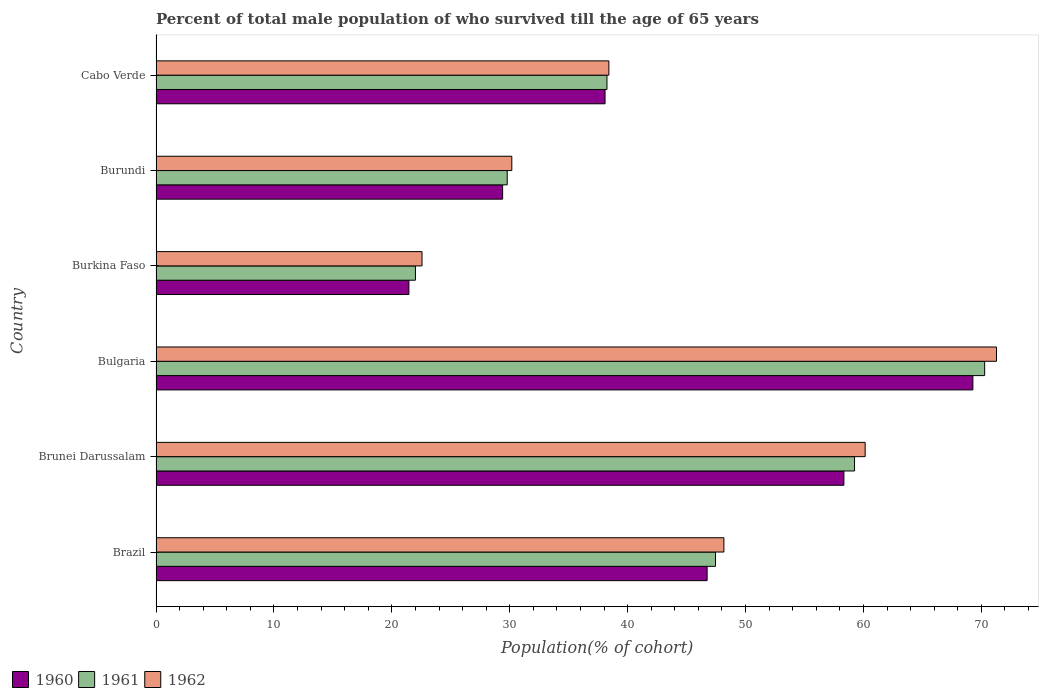How many different coloured bars are there?
Make the answer very short. 3. How many groups of bars are there?
Offer a terse response. 6. Are the number of bars on each tick of the Y-axis equal?
Keep it short and to the point. Yes. How many bars are there on the 2nd tick from the top?
Offer a terse response. 3. What is the label of the 4th group of bars from the top?
Ensure brevity in your answer.  Bulgaria. In how many cases, is the number of bars for a given country not equal to the number of legend labels?
Ensure brevity in your answer.  0. What is the percentage of total male population who survived till the age of 65 years in 1962 in Brazil?
Your answer should be compact. 48.16. Across all countries, what is the maximum percentage of total male population who survived till the age of 65 years in 1961?
Offer a terse response. 70.28. Across all countries, what is the minimum percentage of total male population who survived till the age of 65 years in 1960?
Keep it short and to the point. 21.45. In which country was the percentage of total male population who survived till the age of 65 years in 1962 maximum?
Offer a very short reply. Bulgaria. In which country was the percentage of total male population who survived till the age of 65 years in 1960 minimum?
Your answer should be very brief. Burkina Faso. What is the total percentage of total male population who survived till the age of 65 years in 1961 in the graph?
Offer a very short reply. 267. What is the difference between the percentage of total male population who survived till the age of 65 years in 1961 in Bulgaria and that in Burkina Faso?
Ensure brevity in your answer.  48.28. What is the difference between the percentage of total male population who survived till the age of 65 years in 1961 in Burundi and the percentage of total male population who survived till the age of 65 years in 1962 in Brazil?
Ensure brevity in your answer.  -18.38. What is the average percentage of total male population who survived till the age of 65 years in 1962 per country?
Your answer should be very brief. 45.12. What is the difference between the percentage of total male population who survived till the age of 65 years in 1961 and percentage of total male population who survived till the age of 65 years in 1962 in Cabo Verde?
Offer a very short reply. -0.16. What is the ratio of the percentage of total male population who survived till the age of 65 years in 1961 in Brazil to that in Brunei Darussalam?
Make the answer very short. 0.8. What is the difference between the highest and the second highest percentage of total male population who survived till the age of 65 years in 1960?
Your answer should be very brief. 10.94. What is the difference between the highest and the lowest percentage of total male population who survived till the age of 65 years in 1962?
Give a very brief answer. 48.72. In how many countries, is the percentage of total male population who survived till the age of 65 years in 1962 greater than the average percentage of total male population who survived till the age of 65 years in 1962 taken over all countries?
Offer a terse response. 3. Is the sum of the percentage of total male population who survived till the age of 65 years in 1960 in Bulgaria and Burundi greater than the maximum percentage of total male population who survived till the age of 65 years in 1962 across all countries?
Ensure brevity in your answer.  Yes. What does the 2nd bar from the top in Burkina Faso represents?
Offer a terse response. 1961. What does the 3rd bar from the bottom in Burundi represents?
Offer a terse response. 1962. Is it the case that in every country, the sum of the percentage of total male population who survived till the age of 65 years in 1960 and percentage of total male population who survived till the age of 65 years in 1962 is greater than the percentage of total male population who survived till the age of 65 years in 1961?
Keep it short and to the point. Yes. Are all the bars in the graph horizontal?
Keep it short and to the point. Yes. How many countries are there in the graph?
Your answer should be very brief. 6. Does the graph contain any zero values?
Offer a terse response. No. Does the graph contain grids?
Provide a succinct answer. No. What is the title of the graph?
Your response must be concise. Percent of total male population of who survived till the age of 65 years. What is the label or title of the X-axis?
Offer a very short reply. Population(% of cohort). What is the label or title of the Y-axis?
Keep it short and to the point. Country. What is the Population(% of cohort) in 1960 in Brazil?
Keep it short and to the point. 46.74. What is the Population(% of cohort) in 1961 in Brazil?
Provide a succinct answer. 47.45. What is the Population(% of cohort) of 1962 in Brazil?
Offer a very short reply. 48.16. What is the Population(% of cohort) of 1960 in Brunei Darussalam?
Provide a short and direct response. 58.34. What is the Population(% of cohort) of 1961 in Brunei Darussalam?
Your answer should be compact. 59.24. What is the Population(% of cohort) of 1962 in Brunei Darussalam?
Ensure brevity in your answer.  60.14. What is the Population(% of cohort) of 1960 in Bulgaria?
Make the answer very short. 69.28. What is the Population(% of cohort) in 1961 in Bulgaria?
Your response must be concise. 70.28. What is the Population(% of cohort) of 1962 in Bulgaria?
Provide a succinct answer. 71.28. What is the Population(% of cohort) in 1960 in Burkina Faso?
Give a very brief answer. 21.45. What is the Population(% of cohort) in 1961 in Burkina Faso?
Make the answer very short. 22. What is the Population(% of cohort) in 1962 in Burkina Faso?
Provide a succinct answer. 22.56. What is the Population(% of cohort) of 1960 in Burundi?
Provide a succinct answer. 29.4. What is the Population(% of cohort) in 1961 in Burundi?
Offer a terse response. 29.79. What is the Population(% of cohort) in 1962 in Burundi?
Offer a terse response. 30.17. What is the Population(% of cohort) of 1960 in Cabo Verde?
Provide a short and direct response. 38.08. What is the Population(% of cohort) in 1961 in Cabo Verde?
Your answer should be very brief. 38.24. What is the Population(% of cohort) of 1962 in Cabo Verde?
Keep it short and to the point. 38.41. Across all countries, what is the maximum Population(% of cohort) of 1960?
Ensure brevity in your answer.  69.28. Across all countries, what is the maximum Population(% of cohort) in 1961?
Keep it short and to the point. 70.28. Across all countries, what is the maximum Population(% of cohort) in 1962?
Make the answer very short. 71.28. Across all countries, what is the minimum Population(% of cohort) in 1960?
Your response must be concise. 21.45. Across all countries, what is the minimum Population(% of cohort) in 1961?
Your answer should be compact. 22. Across all countries, what is the minimum Population(% of cohort) in 1962?
Keep it short and to the point. 22.56. What is the total Population(% of cohort) of 1960 in the graph?
Give a very brief answer. 263.28. What is the total Population(% of cohort) of 1961 in the graph?
Provide a succinct answer. 267. What is the total Population(% of cohort) in 1962 in the graph?
Ensure brevity in your answer.  270.72. What is the difference between the Population(% of cohort) of 1960 in Brazil and that in Brunei Darussalam?
Provide a succinct answer. -11.6. What is the difference between the Population(% of cohort) in 1961 in Brazil and that in Brunei Darussalam?
Your answer should be very brief. -11.79. What is the difference between the Population(% of cohort) of 1962 in Brazil and that in Brunei Darussalam?
Your answer should be compact. -11.98. What is the difference between the Population(% of cohort) in 1960 in Brazil and that in Bulgaria?
Make the answer very short. -22.54. What is the difference between the Population(% of cohort) in 1961 in Brazil and that in Bulgaria?
Keep it short and to the point. -22.83. What is the difference between the Population(% of cohort) in 1962 in Brazil and that in Bulgaria?
Your answer should be compact. -23.12. What is the difference between the Population(% of cohort) of 1960 in Brazil and that in Burkina Faso?
Your response must be concise. 25.29. What is the difference between the Population(% of cohort) of 1961 in Brazil and that in Burkina Faso?
Your answer should be very brief. 25.45. What is the difference between the Population(% of cohort) of 1962 in Brazil and that in Burkina Faso?
Provide a short and direct response. 25.6. What is the difference between the Population(% of cohort) of 1960 in Brazil and that in Burundi?
Make the answer very short. 17.34. What is the difference between the Population(% of cohort) of 1961 in Brazil and that in Burundi?
Provide a succinct answer. 17.66. What is the difference between the Population(% of cohort) of 1962 in Brazil and that in Burundi?
Your answer should be compact. 17.99. What is the difference between the Population(% of cohort) in 1960 in Brazil and that in Cabo Verde?
Offer a terse response. 8.66. What is the difference between the Population(% of cohort) of 1961 in Brazil and that in Cabo Verde?
Your answer should be very brief. 9.21. What is the difference between the Population(% of cohort) in 1962 in Brazil and that in Cabo Verde?
Your response must be concise. 9.75. What is the difference between the Population(% of cohort) in 1960 in Brunei Darussalam and that in Bulgaria?
Provide a succinct answer. -10.94. What is the difference between the Population(% of cohort) of 1961 in Brunei Darussalam and that in Bulgaria?
Offer a very short reply. -11.04. What is the difference between the Population(% of cohort) of 1962 in Brunei Darussalam and that in Bulgaria?
Provide a short and direct response. -11.14. What is the difference between the Population(% of cohort) of 1960 in Brunei Darussalam and that in Burkina Faso?
Provide a succinct answer. 36.89. What is the difference between the Population(% of cohort) of 1961 in Brunei Darussalam and that in Burkina Faso?
Provide a succinct answer. 37.24. What is the difference between the Population(% of cohort) of 1962 in Brunei Darussalam and that in Burkina Faso?
Ensure brevity in your answer.  37.58. What is the difference between the Population(% of cohort) in 1960 in Brunei Darussalam and that in Burundi?
Make the answer very short. 28.94. What is the difference between the Population(% of cohort) of 1961 in Brunei Darussalam and that in Burundi?
Keep it short and to the point. 29.46. What is the difference between the Population(% of cohort) of 1962 in Brunei Darussalam and that in Burundi?
Make the answer very short. 29.97. What is the difference between the Population(% of cohort) in 1960 in Brunei Darussalam and that in Cabo Verde?
Give a very brief answer. 20.26. What is the difference between the Population(% of cohort) in 1961 in Brunei Darussalam and that in Cabo Verde?
Your response must be concise. 21. What is the difference between the Population(% of cohort) of 1962 in Brunei Darussalam and that in Cabo Verde?
Provide a succinct answer. 21.73. What is the difference between the Population(% of cohort) in 1960 in Bulgaria and that in Burkina Faso?
Keep it short and to the point. 47.83. What is the difference between the Population(% of cohort) of 1961 in Bulgaria and that in Burkina Faso?
Keep it short and to the point. 48.28. What is the difference between the Population(% of cohort) of 1962 in Bulgaria and that in Burkina Faso?
Your response must be concise. 48.72. What is the difference between the Population(% of cohort) in 1960 in Bulgaria and that in Burundi?
Your response must be concise. 39.88. What is the difference between the Population(% of cohort) in 1961 in Bulgaria and that in Burundi?
Offer a terse response. 40.49. What is the difference between the Population(% of cohort) in 1962 in Bulgaria and that in Burundi?
Provide a short and direct response. 41.1. What is the difference between the Population(% of cohort) in 1960 in Bulgaria and that in Cabo Verde?
Your response must be concise. 31.2. What is the difference between the Population(% of cohort) in 1961 in Bulgaria and that in Cabo Verde?
Your response must be concise. 32.03. What is the difference between the Population(% of cohort) of 1962 in Bulgaria and that in Cabo Verde?
Your answer should be compact. 32.87. What is the difference between the Population(% of cohort) of 1960 in Burkina Faso and that in Burundi?
Make the answer very short. -7.95. What is the difference between the Population(% of cohort) in 1961 in Burkina Faso and that in Burundi?
Your answer should be compact. -7.78. What is the difference between the Population(% of cohort) of 1962 in Burkina Faso and that in Burundi?
Keep it short and to the point. -7.62. What is the difference between the Population(% of cohort) in 1960 in Burkina Faso and that in Cabo Verde?
Your answer should be very brief. -16.64. What is the difference between the Population(% of cohort) of 1961 in Burkina Faso and that in Cabo Verde?
Make the answer very short. -16.24. What is the difference between the Population(% of cohort) of 1962 in Burkina Faso and that in Cabo Verde?
Give a very brief answer. -15.85. What is the difference between the Population(% of cohort) of 1960 in Burundi and that in Cabo Verde?
Offer a very short reply. -8.69. What is the difference between the Population(% of cohort) of 1961 in Burundi and that in Cabo Verde?
Offer a terse response. -8.46. What is the difference between the Population(% of cohort) of 1962 in Burundi and that in Cabo Verde?
Offer a very short reply. -8.23. What is the difference between the Population(% of cohort) of 1960 in Brazil and the Population(% of cohort) of 1961 in Brunei Darussalam?
Make the answer very short. -12.5. What is the difference between the Population(% of cohort) of 1960 in Brazil and the Population(% of cohort) of 1962 in Brunei Darussalam?
Give a very brief answer. -13.4. What is the difference between the Population(% of cohort) of 1961 in Brazil and the Population(% of cohort) of 1962 in Brunei Darussalam?
Offer a terse response. -12.69. What is the difference between the Population(% of cohort) in 1960 in Brazil and the Population(% of cohort) in 1961 in Bulgaria?
Your response must be concise. -23.54. What is the difference between the Population(% of cohort) of 1960 in Brazil and the Population(% of cohort) of 1962 in Bulgaria?
Keep it short and to the point. -24.54. What is the difference between the Population(% of cohort) of 1961 in Brazil and the Population(% of cohort) of 1962 in Bulgaria?
Provide a succinct answer. -23.83. What is the difference between the Population(% of cohort) in 1960 in Brazil and the Population(% of cohort) in 1961 in Burkina Faso?
Provide a succinct answer. 24.74. What is the difference between the Population(% of cohort) of 1960 in Brazil and the Population(% of cohort) of 1962 in Burkina Faso?
Give a very brief answer. 24.18. What is the difference between the Population(% of cohort) of 1961 in Brazil and the Population(% of cohort) of 1962 in Burkina Faso?
Provide a succinct answer. 24.89. What is the difference between the Population(% of cohort) in 1960 in Brazil and the Population(% of cohort) in 1961 in Burundi?
Your answer should be very brief. 16.95. What is the difference between the Population(% of cohort) of 1960 in Brazil and the Population(% of cohort) of 1962 in Burundi?
Your answer should be very brief. 16.56. What is the difference between the Population(% of cohort) of 1961 in Brazil and the Population(% of cohort) of 1962 in Burundi?
Offer a terse response. 17.28. What is the difference between the Population(% of cohort) in 1960 in Brazil and the Population(% of cohort) in 1961 in Cabo Verde?
Provide a succinct answer. 8.49. What is the difference between the Population(% of cohort) of 1960 in Brazil and the Population(% of cohort) of 1962 in Cabo Verde?
Offer a very short reply. 8.33. What is the difference between the Population(% of cohort) in 1961 in Brazil and the Population(% of cohort) in 1962 in Cabo Verde?
Offer a very short reply. 9.04. What is the difference between the Population(% of cohort) in 1960 in Brunei Darussalam and the Population(% of cohort) in 1961 in Bulgaria?
Ensure brevity in your answer.  -11.94. What is the difference between the Population(% of cohort) in 1960 in Brunei Darussalam and the Population(% of cohort) in 1962 in Bulgaria?
Offer a very short reply. -12.94. What is the difference between the Population(% of cohort) in 1961 in Brunei Darussalam and the Population(% of cohort) in 1962 in Bulgaria?
Make the answer very short. -12.04. What is the difference between the Population(% of cohort) in 1960 in Brunei Darussalam and the Population(% of cohort) in 1961 in Burkina Faso?
Your answer should be compact. 36.34. What is the difference between the Population(% of cohort) in 1960 in Brunei Darussalam and the Population(% of cohort) in 1962 in Burkina Faso?
Your response must be concise. 35.78. What is the difference between the Population(% of cohort) in 1961 in Brunei Darussalam and the Population(% of cohort) in 1962 in Burkina Faso?
Offer a very short reply. 36.68. What is the difference between the Population(% of cohort) in 1960 in Brunei Darussalam and the Population(% of cohort) in 1961 in Burundi?
Your answer should be compact. 28.55. What is the difference between the Population(% of cohort) in 1960 in Brunei Darussalam and the Population(% of cohort) in 1962 in Burundi?
Your answer should be very brief. 28.16. What is the difference between the Population(% of cohort) in 1961 in Brunei Darussalam and the Population(% of cohort) in 1962 in Burundi?
Your answer should be compact. 29.07. What is the difference between the Population(% of cohort) of 1960 in Brunei Darussalam and the Population(% of cohort) of 1961 in Cabo Verde?
Ensure brevity in your answer.  20.09. What is the difference between the Population(% of cohort) of 1960 in Brunei Darussalam and the Population(% of cohort) of 1962 in Cabo Verde?
Make the answer very short. 19.93. What is the difference between the Population(% of cohort) in 1961 in Brunei Darussalam and the Population(% of cohort) in 1962 in Cabo Verde?
Ensure brevity in your answer.  20.83. What is the difference between the Population(% of cohort) in 1960 in Bulgaria and the Population(% of cohort) in 1961 in Burkina Faso?
Provide a succinct answer. 47.28. What is the difference between the Population(% of cohort) of 1960 in Bulgaria and the Population(% of cohort) of 1962 in Burkina Faso?
Make the answer very short. 46.72. What is the difference between the Population(% of cohort) of 1961 in Bulgaria and the Population(% of cohort) of 1962 in Burkina Faso?
Ensure brevity in your answer.  47.72. What is the difference between the Population(% of cohort) in 1960 in Bulgaria and the Population(% of cohort) in 1961 in Burundi?
Your response must be concise. 39.49. What is the difference between the Population(% of cohort) in 1960 in Bulgaria and the Population(% of cohort) in 1962 in Burundi?
Your answer should be compact. 39.1. What is the difference between the Population(% of cohort) in 1961 in Bulgaria and the Population(% of cohort) in 1962 in Burundi?
Your response must be concise. 40.1. What is the difference between the Population(% of cohort) of 1960 in Bulgaria and the Population(% of cohort) of 1961 in Cabo Verde?
Ensure brevity in your answer.  31.03. What is the difference between the Population(% of cohort) of 1960 in Bulgaria and the Population(% of cohort) of 1962 in Cabo Verde?
Keep it short and to the point. 30.87. What is the difference between the Population(% of cohort) of 1961 in Bulgaria and the Population(% of cohort) of 1962 in Cabo Verde?
Provide a short and direct response. 31.87. What is the difference between the Population(% of cohort) in 1960 in Burkina Faso and the Population(% of cohort) in 1961 in Burundi?
Offer a very short reply. -8.34. What is the difference between the Population(% of cohort) of 1960 in Burkina Faso and the Population(% of cohort) of 1962 in Burundi?
Provide a short and direct response. -8.73. What is the difference between the Population(% of cohort) in 1961 in Burkina Faso and the Population(% of cohort) in 1962 in Burundi?
Your answer should be very brief. -8.17. What is the difference between the Population(% of cohort) in 1960 in Burkina Faso and the Population(% of cohort) in 1961 in Cabo Verde?
Your response must be concise. -16.8. What is the difference between the Population(% of cohort) of 1960 in Burkina Faso and the Population(% of cohort) of 1962 in Cabo Verde?
Make the answer very short. -16.96. What is the difference between the Population(% of cohort) in 1961 in Burkina Faso and the Population(% of cohort) in 1962 in Cabo Verde?
Offer a terse response. -16.4. What is the difference between the Population(% of cohort) in 1960 in Burundi and the Population(% of cohort) in 1961 in Cabo Verde?
Ensure brevity in your answer.  -8.85. What is the difference between the Population(% of cohort) in 1960 in Burundi and the Population(% of cohort) in 1962 in Cabo Verde?
Your answer should be very brief. -9.01. What is the difference between the Population(% of cohort) in 1961 in Burundi and the Population(% of cohort) in 1962 in Cabo Verde?
Make the answer very short. -8.62. What is the average Population(% of cohort) of 1960 per country?
Give a very brief answer. 43.88. What is the average Population(% of cohort) in 1961 per country?
Your answer should be very brief. 44.5. What is the average Population(% of cohort) in 1962 per country?
Provide a short and direct response. 45.12. What is the difference between the Population(% of cohort) of 1960 and Population(% of cohort) of 1961 in Brazil?
Offer a very short reply. -0.71. What is the difference between the Population(% of cohort) of 1960 and Population(% of cohort) of 1962 in Brazil?
Your response must be concise. -1.42. What is the difference between the Population(% of cohort) of 1961 and Population(% of cohort) of 1962 in Brazil?
Your answer should be very brief. -0.71. What is the difference between the Population(% of cohort) in 1960 and Population(% of cohort) in 1961 in Brunei Darussalam?
Provide a succinct answer. -0.9. What is the difference between the Population(% of cohort) of 1960 and Population(% of cohort) of 1962 in Brunei Darussalam?
Keep it short and to the point. -1.8. What is the difference between the Population(% of cohort) of 1961 and Population(% of cohort) of 1962 in Brunei Darussalam?
Provide a succinct answer. -0.9. What is the difference between the Population(% of cohort) of 1960 and Population(% of cohort) of 1961 in Bulgaria?
Provide a succinct answer. -1. What is the difference between the Population(% of cohort) of 1960 and Population(% of cohort) of 1962 in Bulgaria?
Your answer should be compact. -2. What is the difference between the Population(% of cohort) of 1960 and Population(% of cohort) of 1961 in Burkina Faso?
Provide a succinct answer. -0.56. What is the difference between the Population(% of cohort) of 1960 and Population(% of cohort) of 1962 in Burkina Faso?
Give a very brief answer. -1.11. What is the difference between the Population(% of cohort) in 1961 and Population(% of cohort) in 1962 in Burkina Faso?
Your answer should be very brief. -0.56. What is the difference between the Population(% of cohort) in 1960 and Population(% of cohort) in 1961 in Burundi?
Your answer should be compact. -0.39. What is the difference between the Population(% of cohort) in 1960 and Population(% of cohort) in 1962 in Burundi?
Provide a succinct answer. -0.78. What is the difference between the Population(% of cohort) in 1961 and Population(% of cohort) in 1962 in Burundi?
Provide a short and direct response. -0.39. What is the difference between the Population(% of cohort) of 1960 and Population(% of cohort) of 1961 in Cabo Verde?
Provide a short and direct response. -0.16. What is the difference between the Population(% of cohort) of 1960 and Population(% of cohort) of 1962 in Cabo Verde?
Offer a very short reply. -0.32. What is the difference between the Population(% of cohort) of 1961 and Population(% of cohort) of 1962 in Cabo Verde?
Make the answer very short. -0.16. What is the ratio of the Population(% of cohort) of 1960 in Brazil to that in Brunei Darussalam?
Keep it short and to the point. 0.8. What is the ratio of the Population(% of cohort) of 1961 in Brazil to that in Brunei Darussalam?
Keep it short and to the point. 0.8. What is the ratio of the Population(% of cohort) in 1962 in Brazil to that in Brunei Darussalam?
Offer a very short reply. 0.8. What is the ratio of the Population(% of cohort) in 1960 in Brazil to that in Bulgaria?
Give a very brief answer. 0.67. What is the ratio of the Population(% of cohort) in 1961 in Brazil to that in Bulgaria?
Offer a very short reply. 0.68. What is the ratio of the Population(% of cohort) in 1962 in Brazil to that in Bulgaria?
Your answer should be very brief. 0.68. What is the ratio of the Population(% of cohort) of 1960 in Brazil to that in Burkina Faso?
Make the answer very short. 2.18. What is the ratio of the Population(% of cohort) in 1961 in Brazil to that in Burkina Faso?
Provide a succinct answer. 2.16. What is the ratio of the Population(% of cohort) of 1962 in Brazil to that in Burkina Faso?
Your answer should be very brief. 2.13. What is the ratio of the Population(% of cohort) of 1960 in Brazil to that in Burundi?
Give a very brief answer. 1.59. What is the ratio of the Population(% of cohort) of 1961 in Brazil to that in Burundi?
Offer a very short reply. 1.59. What is the ratio of the Population(% of cohort) of 1962 in Brazil to that in Burundi?
Offer a terse response. 1.6. What is the ratio of the Population(% of cohort) of 1960 in Brazil to that in Cabo Verde?
Provide a succinct answer. 1.23. What is the ratio of the Population(% of cohort) in 1961 in Brazil to that in Cabo Verde?
Provide a succinct answer. 1.24. What is the ratio of the Population(% of cohort) of 1962 in Brazil to that in Cabo Verde?
Your answer should be compact. 1.25. What is the ratio of the Population(% of cohort) of 1960 in Brunei Darussalam to that in Bulgaria?
Keep it short and to the point. 0.84. What is the ratio of the Population(% of cohort) in 1961 in Brunei Darussalam to that in Bulgaria?
Offer a terse response. 0.84. What is the ratio of the Population(% of cohort) of 1962 in Brunei Darussalam to that in Bulgaria?
Ensure brevity in your answer.  0.84. What is the ratio of the Population(% of cohort) of 1960 in Brunei Darussalam to that in Burkina Faso?
Provide a succinct answer. 2.72. What is the ratio of the Population(% of cohort) of 1961 in Brunei Darussalam to that in Burkina Faso?
Your answer should be very brief. 2.69. What is the ratio of the Population(% of cohort) of 1962 in Brunei Darussalam to that in Burkina Faso?
Your response must be concise. 2.67. What is the ratio of the Population(% of cohort) of 1960 in Brunei Darussalam to that in Burundi?
Offer a terse response. 1.98. What is the ratio of the Population(% of cohort) of 1961 in Brunei Darussalam to that in Burundi?
Your response must be concise. 1.99. What is the ratio of the Population(% of cohort) in 1962 in Brunei Darussalam to that in Burundi?
Your answer should be very brief. 1.99. What is the ratio of the Population(% of cohort) in 1960 in Brunei Darussalam to that in Cabo Verde?
Your answer should be compact. 1.53. What is the ratio of the Population(% of cohort) in 1961 in Brunei Darussalam to that in Cabo Verde?
Keep it short and to the point. 1.55. What is the ratio of the Population(% of cohort) of 1962 in Brunei Darussalam to that in Cabo Verde?
Your answer should be compact. 1.57. What is the ratio of the Population(% of cohort) of 1960 in Bulgaria to that in Burkina Faso?
Offer a very short reply. 3.23. What is the ratio of the Population(% of cohort) of 1961 in Bulgaria to that in Burkina Faso?
Provide a succinct answer. 3.19. What is the ratio of the Population(% of cohort) in 1962 in Bulgaria to that in Burkina Faso?
Keep it short and to the point. 3.16. What is the ratio of the Population(% of cohort) in 1960 in Bulgaria to that in Burundi?
Give a very brief answer. 2.36. What is the ratio of the Population(% of cohort) in 1961 in Bulgaria to that in Burundi?
Offer a terse response. 2.36. What is the ratio of the Population(% of cohort) of 1962 in Bulgaria to that in Burundi?
Give a very brief answer. 2.36. What is the ratio of the Population(% of cohort) of 1960 in Bulgaria to that in Cabo Verde?
Provide a succinct answer. 1.82. What is the ratio of the Population(% of cohort) in 1961 in Bulgaria to that in Cabo Verde?
Your response must be concise. 1.84. What is the ratio of the Population(% of cohort) of 1962 in Bulgaria to that in Cabo Verde?
Offer a very short reply. 1.86. What is the ratio of the Population(% of cohort) in 1960 in Burkina Faso to that in Burundi?
Provide a succinct answer. 0.73. What is the ratio of the Population(% of cohort) in 1961 in Burkina Faso to that in Burundi?
Provide a short and direct response. 0.74. What is the ratio of the Population(% of cohort) in 1962 in Burkina Faso to that in Burundi?
Provide a short and direct response. 0.75. What is the ratio of the Population(% of cohort) in 1960 in Burkina Faso to that in Cabo Verde?
Give a very brief answer. 0.56. What is the ratio of the Population(% of cohort) of 1961 in Burkina Faso to that in Cabo Verde?
Make the answer very short. 0.58. What is the ratio of the Population(% of cohort) of 1962 in Burkina Faso to that in Cabo Verde?
Your answer should be very brief. 0.59. What is the ratio of the Population(% of cohort) of 1960 in Burundi to that in Cabo Verde?
Offer a terse response. 0.77. What is the ratio of the Population(% of cohort) in 1961 in Burundi to that in Cabo Verde?
Keep it short and to the point. 0.78. What is the ratio of the Population(% of cohort) of 1962 in Burundi to that in Cabo Verde?
Your answer should be compact. 0.79. What is the difference between the highest and the second highest Population(% of cohort) in 1960?
Make the answer very short. 10.94. What is the difference between the highest and the second highest Population(% of cohort) of 1961?
Provide a short and direct response. 11.04. What is the difference between the highest and the second highest Population(% of cohort) of 1962?
Give a very brief answer. 11.14. What is the difference between the highest and the lowest Population(% of cohort) in 1960?
Provide a succinct answer. 47.83. What is the difference between the highest and the lowest Population(% of cohort) of 1961?
Offer a terse response. 48.28. What is the difference between the highest and the lowest Population(% of cohort) in 1962?
Give a very brief answer. 48.72. 